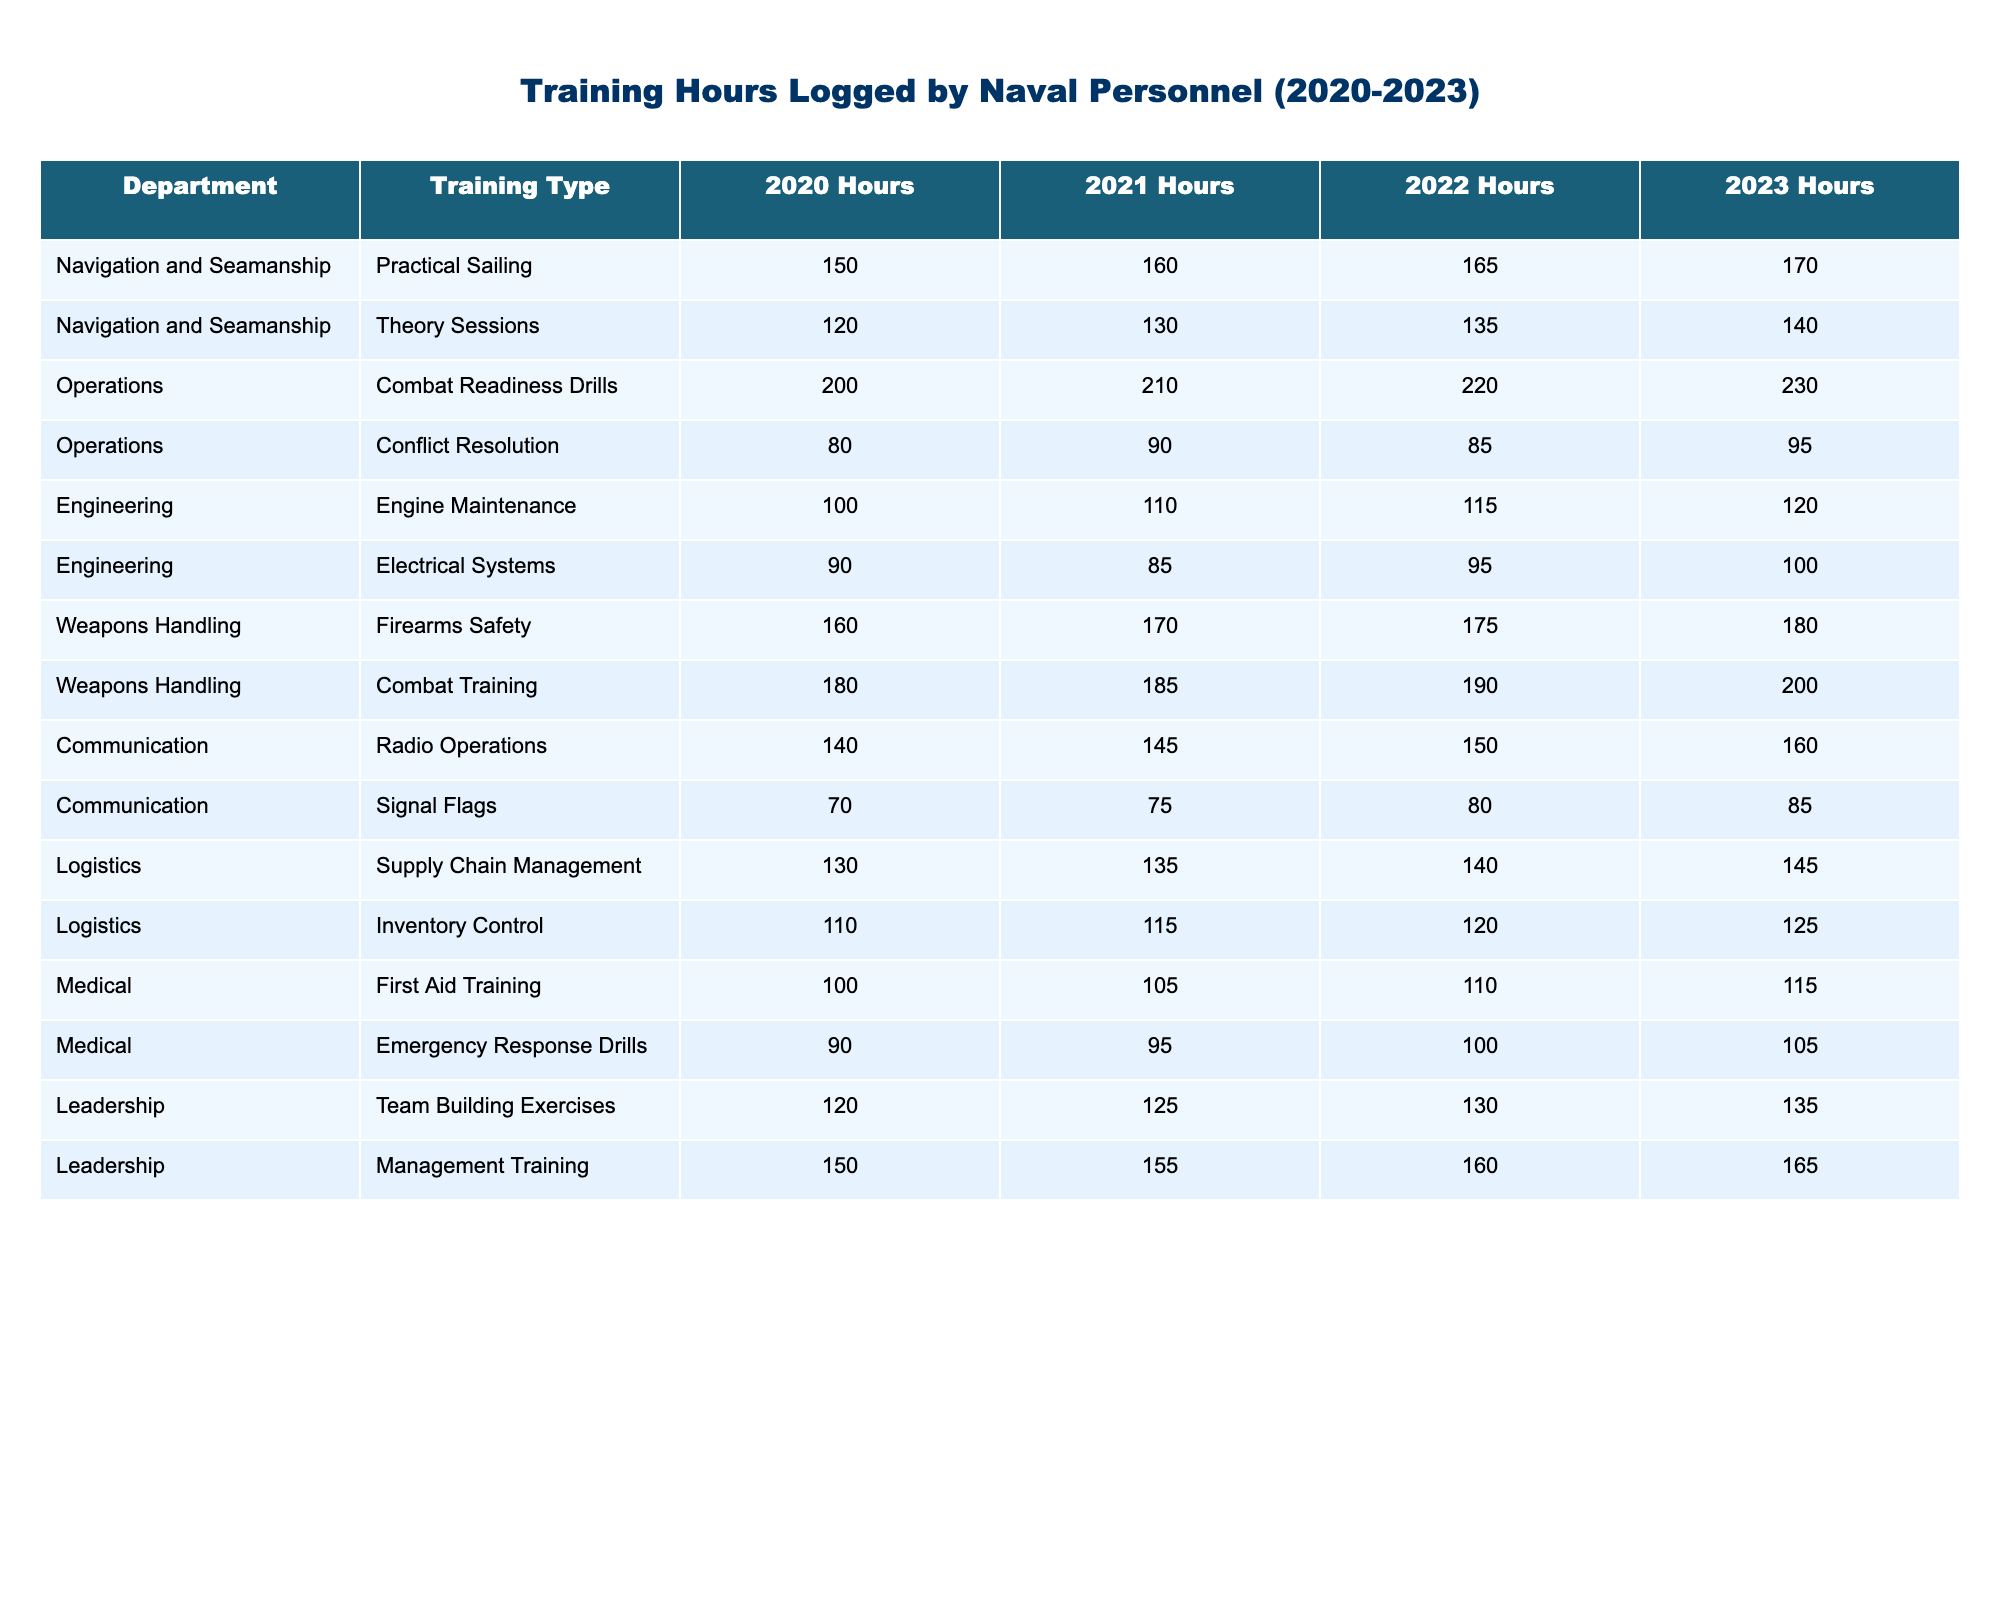What is the total training hours logged by the Engineering department in 2022? The Engineering department logged 115 hours for Engine Maintenance and 95 hours for Electrical Systems in 2022. Adding these values gives 115 + 95 = 210 hours.
Answer: 210 hours Which training type had the highest logged hours in 2023? In 2023, the highest logged hours were for Combat Training with 200 hours compared to other training types.
Answer: Combat Training How many hours did the Logistics department increase its training hours from 2020 to 2023? The Logistics department logged 130 hours in 2020 and 145 hours in 2023. The difference is 145 - 130 = 15 hours.
Answer: 15 hours Did the Training Type "Signal Flags" see an increase in training hours from 2020 to 2023? For Signal Flags, the hours increased from 70 in 2020 to 85 in 2023, therefore it did see an increase.
Answer: Yes What is the average training hours logged by the Medical department from 2020 to 2023? The Medical department logged 100, 90, 105, and 100 hours over four years. Summing these gives a total of 100 + 90 + 105 + 100 = 395. The average would be 395 / 4 = 98.75 hours.
Answer: 98.75 hours Which department had the highest combined training hours for both Practical Sailing and Theory Sessions in 2023? The Navigation and Seamanship department logged 170 hours for Practical Sailing and 140 hours for Theory Sessions, giving a total of 170 + 140 = 310 hours.
Answer: Navigation and Seamanship What was the logged hour difference for "Combat Readiness Drills" between 2020 and 2023? In 2020, the hours were 200 and in 2023 they were 230. The difference is 230 - 200 = 30 hours.
Answer: 30 hours Which two departments had the lowest total training hours in 2021? The Medical department logged 105 hours and 95 hours respectively in 2021, giving a total of 200 hours. The Engineering department logged 110 hours and 85 hours for a total of 195 hours, which is lower than the Medical department.
Answer: Engineering department Is the total logged hours in 2022 for "First Aid Training" more than that for "Emergency Response Drills"? First Aid Training logged 110 hours while Emergency Response Drills logged 100 hours, so it is more.
Answer: Yes Which department showed a consistent increase in training hours from 2020 to 2023? Upon reviewing, the Operations department showed an increase each year: 200 in 2020, 210 in 2021, 220 in 2022, and 230 in 2023.
Answer: Operations department What was the total training hours for the Weapons Handling department over the four years? Firearms Safety logged 170, 175, 180, and Combat Training logged 180, 185, 190, resulting in totals of 170 + 175 + 180 + 200 = 725 hours.
Answer: 725 hours 